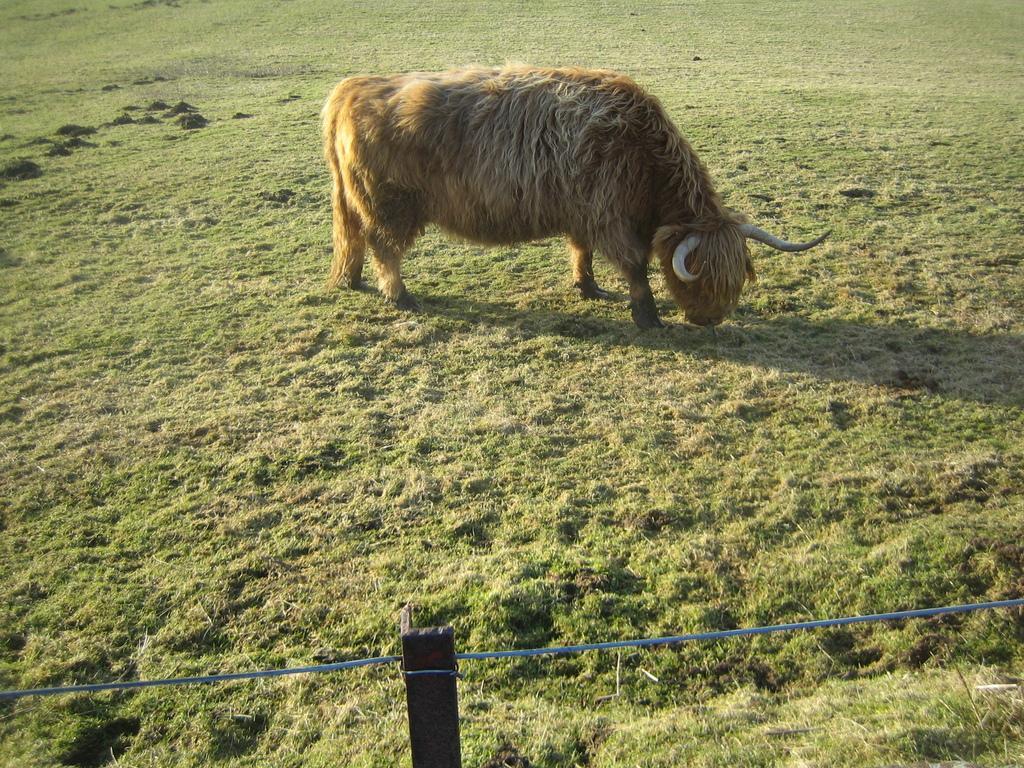Describe this image in one or two sentences. In this image we can see one animal eating grass on the ground, one fence with wooden pole and some grass on the ground. 